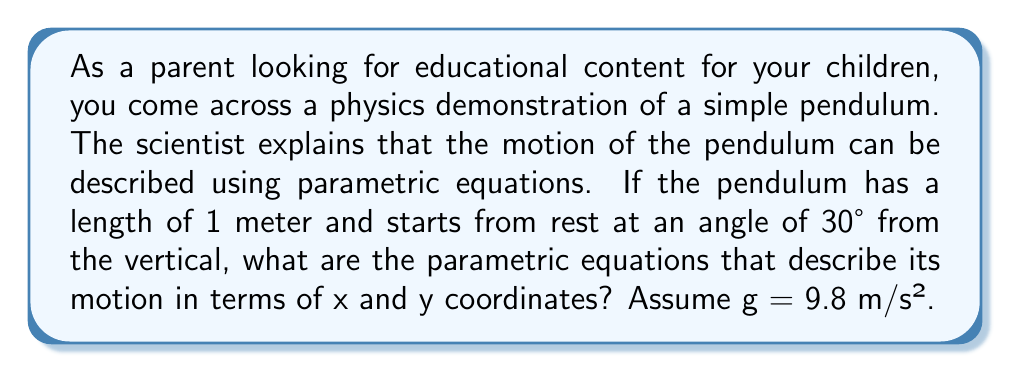Could you help me with this problem? Let's approach this step-by-step:

1) For a simple pendulum, the motion can be described using parametric equations:

   $x = L \sin(\theta)$
   $y = -L \cos(\theta)$

   Where L is the length of the pendulum and $\theta$ is the angle from the vertical.

2) For small angles, the motion of a pendulum is approximately simple harmonic motion. The angle $\theta$ as a function of time is given by:

   $\theta(t) = \theta_0 \cos(\omega t)$

   Where $\theta_0$ is the initial angle and $\omega$ is the angular frequency.

3) The angular frequency $\omega$ is given by:

   $\omega = \sqrt{\frac{g}{L}}$

   Where g is the acceleration due to gravity and L is the length of the pendulum.

4) Given:
   - L = 1 meter
   - g = 9.8 m/s²
   - $\theta_0 = 30° = \frac{\pi}{6}$ radians

5) Calculate $\omega$:

   $\omega = \sqrt{\frac{9.8}{1}} = \sqrt{9.8} \approx 3.13$ rad/s

6) Now we can write $\theta(t)$:

   $\theta(t) = \frac{\pi}{6} \cos(3.13t)$

7) Substituting this into our parametric equations:

   $x(t) = \sin(\frac{\pi}{6} \cos(3.13t))$
   $y(t) = -\cos(\frac{\pi}{6} \cos(3.13t))$

These are the parametric equations describing the motion of the pendulum.
Answer: The parametric equations describing the motion of the pendulum are:

$x(t) = \sin(\frac{\pi}{6} \cos(3.13t))$
$y(t) = -\cos(\frac{\pi}{6} \cos(3.13t))$

Where t is time in seconds. 